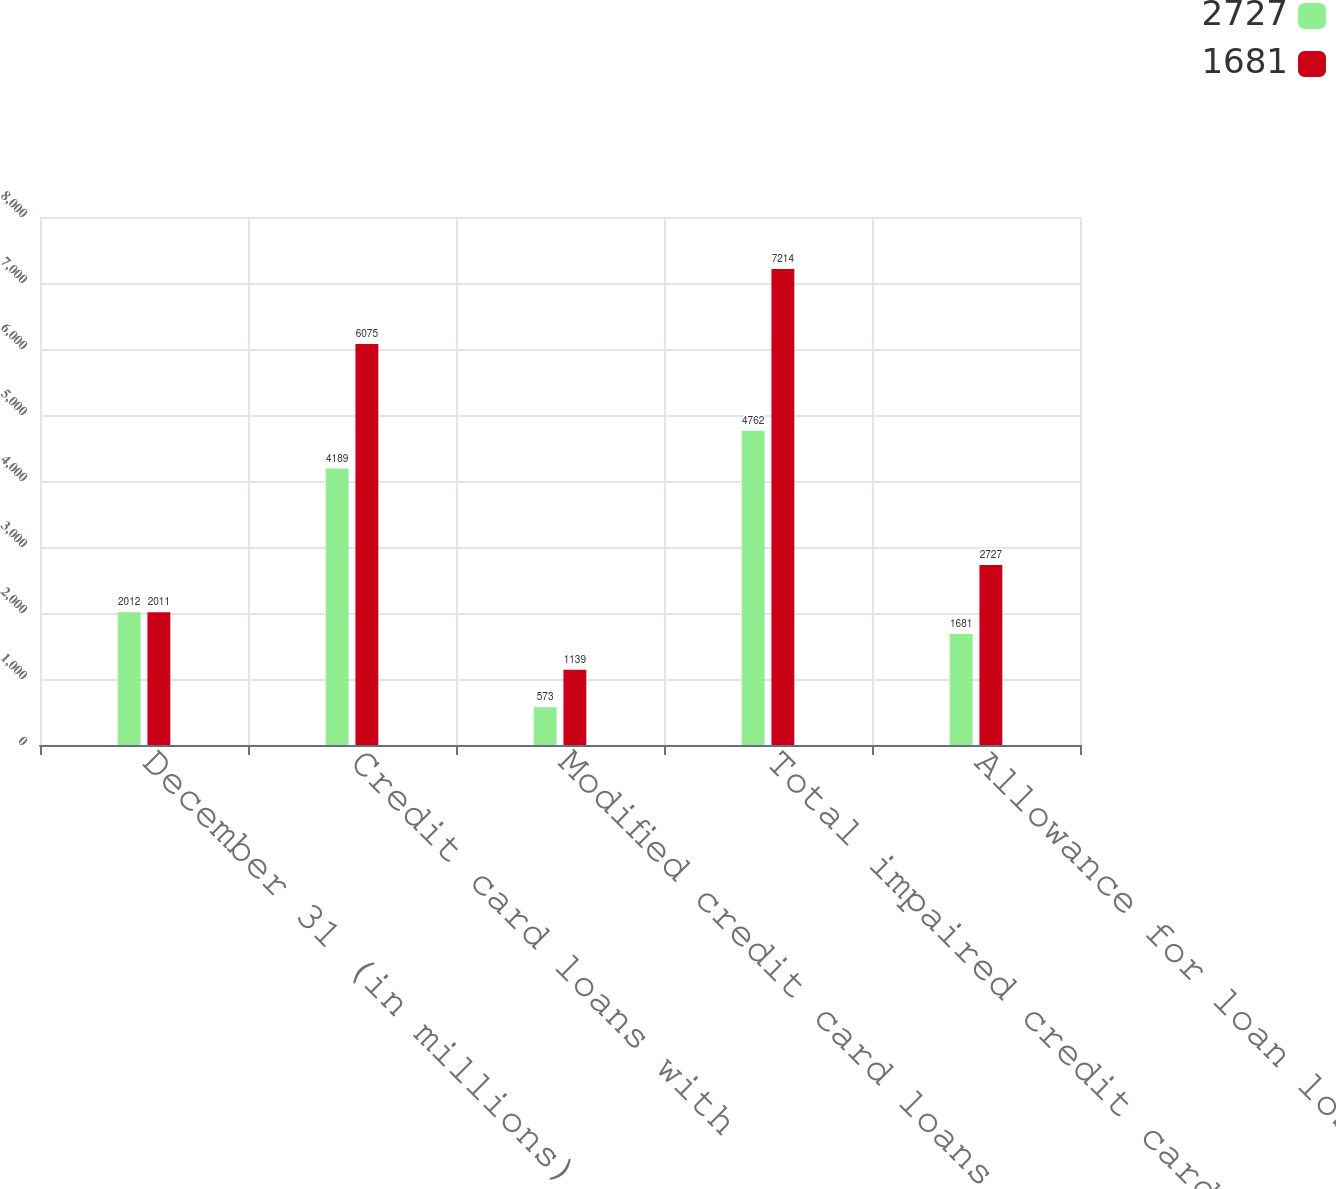<chart> <loc_0><loc_0><loc_500><loc_500><stacked_bar_chart><ecel><fcel>December 31 (in millions)<fcel>Credit card loans with<fcel>Modified credit card loans<fcel>Total impaired credit card<fcel>Allowance for loan losses<nl><fcel>2727<fcel>2012<fcel>4189<fcel>573<fcel>4762<fcel>1681<nl><fcel>1681<fcel>2011<fcel>6075<fcel>1139<fcel>7214<fcel>2727<nl></chart> 